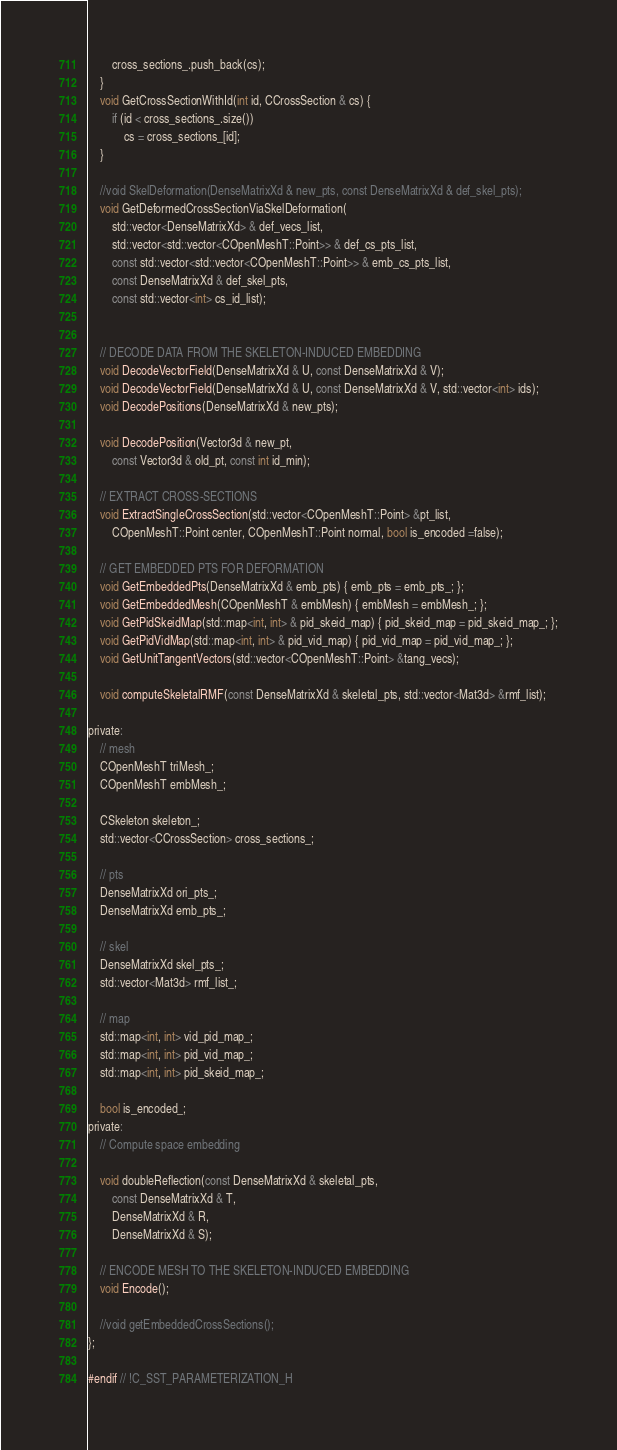Convert code to text. <code><loc_0><loc_0><loc_500><loc_500><_C_>		cross_sections_.push_back(cs);
	}
	void GetCrossSectionWithId(int id, CCrossSection & cs) {
		if (id < cross_sections_.size())
			cs = cross_sections_[id];
	}

	//void SkelDeformation(DenseMatrixXd & new_pts, const DenseMatrixXd & def_skel_pts);
	void GetDeformedCrossSectionViaSkelDeformation(
		std::vector<DenseMatrixXd> & def_vecs_list,
		std::vector<std::vector<COpenMeshT::Point>> & def_cs_pts_list,
		const std::vector<std::vector<COpenMeshT::Point>> & emb_cs_pts_list,
		const DenseMatrixXd & def_skel_pts,
		const std::vector<int> cs_id_list);


	// DECODE DATA FROM THE SKELETON-INDUCED EMBEDDING
	void DecodeVectorField(DenseMatrixXd & U, const DenseMatrixXd & V);
	void DecodeVectorField(DenseMatrixXd & U, const DenseMatrixXd & V, std::vector<int> ids);
	void DecodePositions(DenseMatrixXd & new_pts);
	
	void DecodePosition(Vector3d & new_pt, 
		const Vector3d & old_pt, const int id_min);

	// EXTRACT CROSS-SECTIONS
	void ExtractSingleCrossSection(std::vector<COpenMeshT::Point> &pt_list,
		COpenMeshT::Point center, COpenMeshT::Point normal, bool is_encoded =false);

	// GET EMBEDDED PTS FOR DEFORMATION
	void GetEmbeddedPts(DenseMatrixXd & emb_pts) { emb_pts = emb_pts_; };
	void GetEmbeddedMesh(COpenMeshT & embMesh) { embMesh = embMesh_; };
	void GetPidSkeidMap(std::map<int, int> & pid_skeid_map) { pid_skeid_map = pid_skeid_map_; };
	void GetPidVidMap(std::map<int, int> & pid_vid_map) { pid_vid_map = pid_vid_map_; };
	void GetUnitTangentVectors(std::vector<COpenMeshT::Point> &tang_vecs);

	void computeSkeletalRMF(const DenseMatrixXd & skeletal_pts, std::vector<Mat3d> &rmf_list);

private:
	// mesh
	COpenMeshT triMesh_;
	COpenMeshT embMesh_;

	CSkeleton skeleton_;
	std::vector<CCrossSection> cross_sections_;

	// pts
	DenseMatrixXd ori_pts_;
	DenseMatrixXd emb_pts_;
	
	// skel
	DenseMatrixXd skel_pts_;
	std::vector<Mat3d> rmf_list_;

	// map
	std::map<int, int> vid_pid_map_;
	std::map<int, int> pid_vid_map_;
	std::map<int, int> pid_skeid_map_;

	bool is_encoded_;
private:
	// Compute space embedding
	
	void doubleReflection(const DenseMatrixXd & skeletal_pts,
		const DenseMatrixXd & T,
		DenseMatrixXd & R,
		DenseMatrixXd & S);

	// ENCODE MESH TO THE SKELETON-INDUCED EMBEDDING
	void Encode();

	//void getEmbeddedCrossSections();
};

#endif // !C_SST_PARAMETERIZATION_H



</code> 